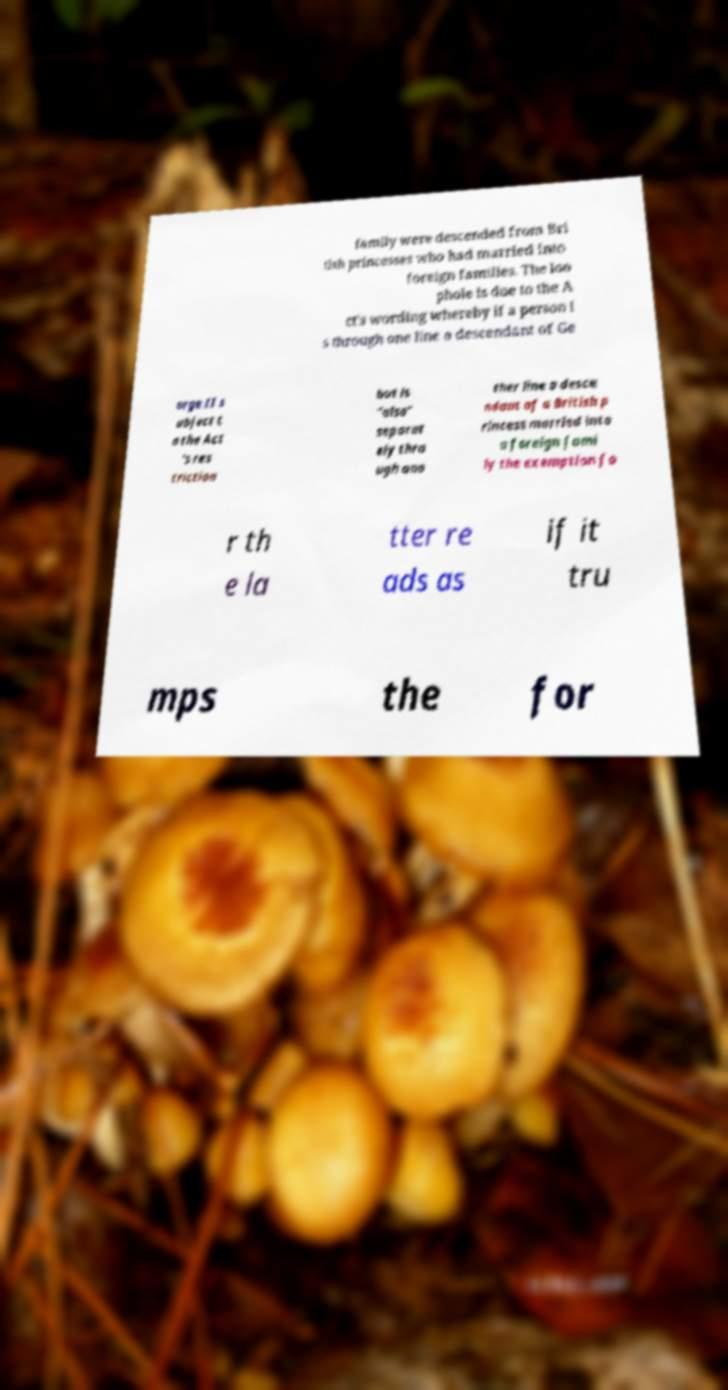Could you assist in decoding the text presented in this image and type it out clearly? family were descended from Bri tish princesses who had married into foreign families. The loo phole is due to the A ct's wording whereby if a person i s through one line a descendant of Ge orge II s ubject t o the Act 's res triction but is "also" separat ely thro ugh ano ther line a desce ndant of a British p rincess married into a foreign fami ly the exemption fo r th e la tter re ads as if it tru mps the for 